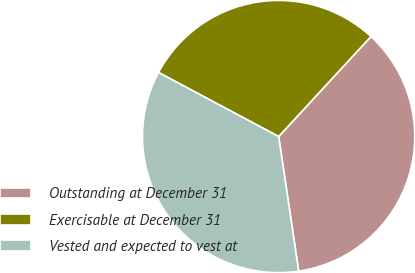<chart> <loc_0><loc_0><loc_500><loc_500><pie_chart><fcel>Outstanding at December 31<fcel>Exercisable at December 31<fcel>Vested and expected to vest at<nl><fcel>35.79%<fcel>29.07%<fcel>35.15%<nl></chart> 